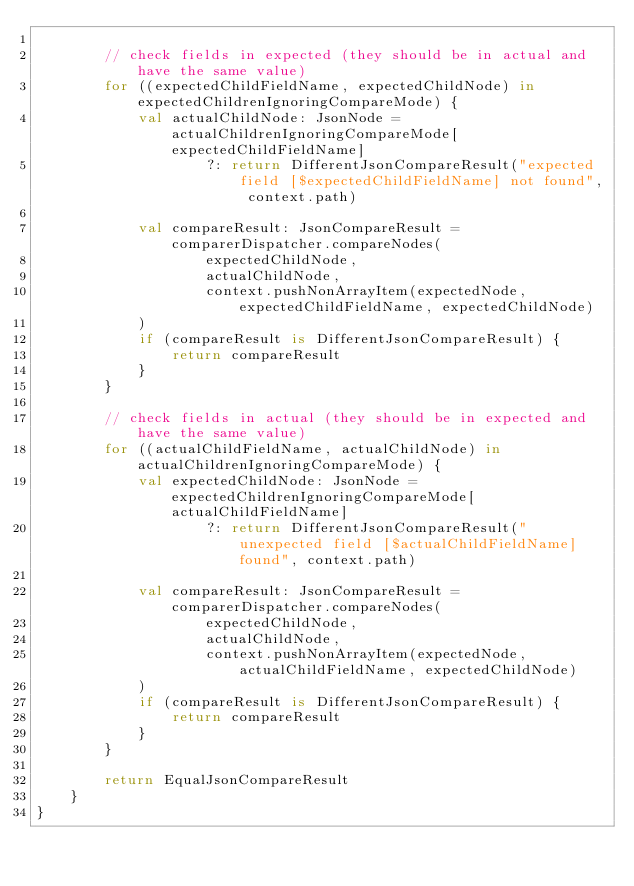Convert code to text. <code><loc_0><loc_0><loc_500><loc_500><_Kotlin_>
        // check fields in expected (they should be in actual and have the same value)
        for ((expectedChildFieldName, expectedChildNode) in expectedChildrenIgnoringCompareMode) {
            val actualChildNode: JsonNode = actualChildrenIgnoringCompareMode[expectedChildFieldName]
                    ?: return DifferentJsonCompareResult("expected field [$expectedChildFieldName] not found", context.path)

            val compareResult: JsonCompareResult = comparerDispatcher.compareNodes(
                    expectedChildNode,
                    actualChildNode,
                    context.pushNonArrayItem(expectedNode, expectedChildFieldName, expectedChildNode)
            )
            if (compareResult is DifferentJsonCompareResult) {
                return compareResult
            }
        }

        // check fields in actual (they should be in expected and have the same value)
        for ((actualChildFieldName, actualChildNode) in actualChildrenIgnoringCompareMode) {
            val expectedChildNode: JsonNode = expectedChildrenIgnoringCompareMode[actualChildFieldName]
                    ?: return DifferentJsonCompareResult("unexpected field [$actualChildFieldName] found", context.path)

            val compareResult: JsonCompareResult = comparerDispatcher.compareNodes(
                    expectedChildNode,
                    actualChildNode,
                    context.pushNonArrayItem(expectedNode, actualChildFieldName, expectedChildNode)
            )
            if (compareResult is DifferentJsonCompareResult) {
                return compareResult
            }
        }

        return EqualJsonCompareResult
    }
}</code> 